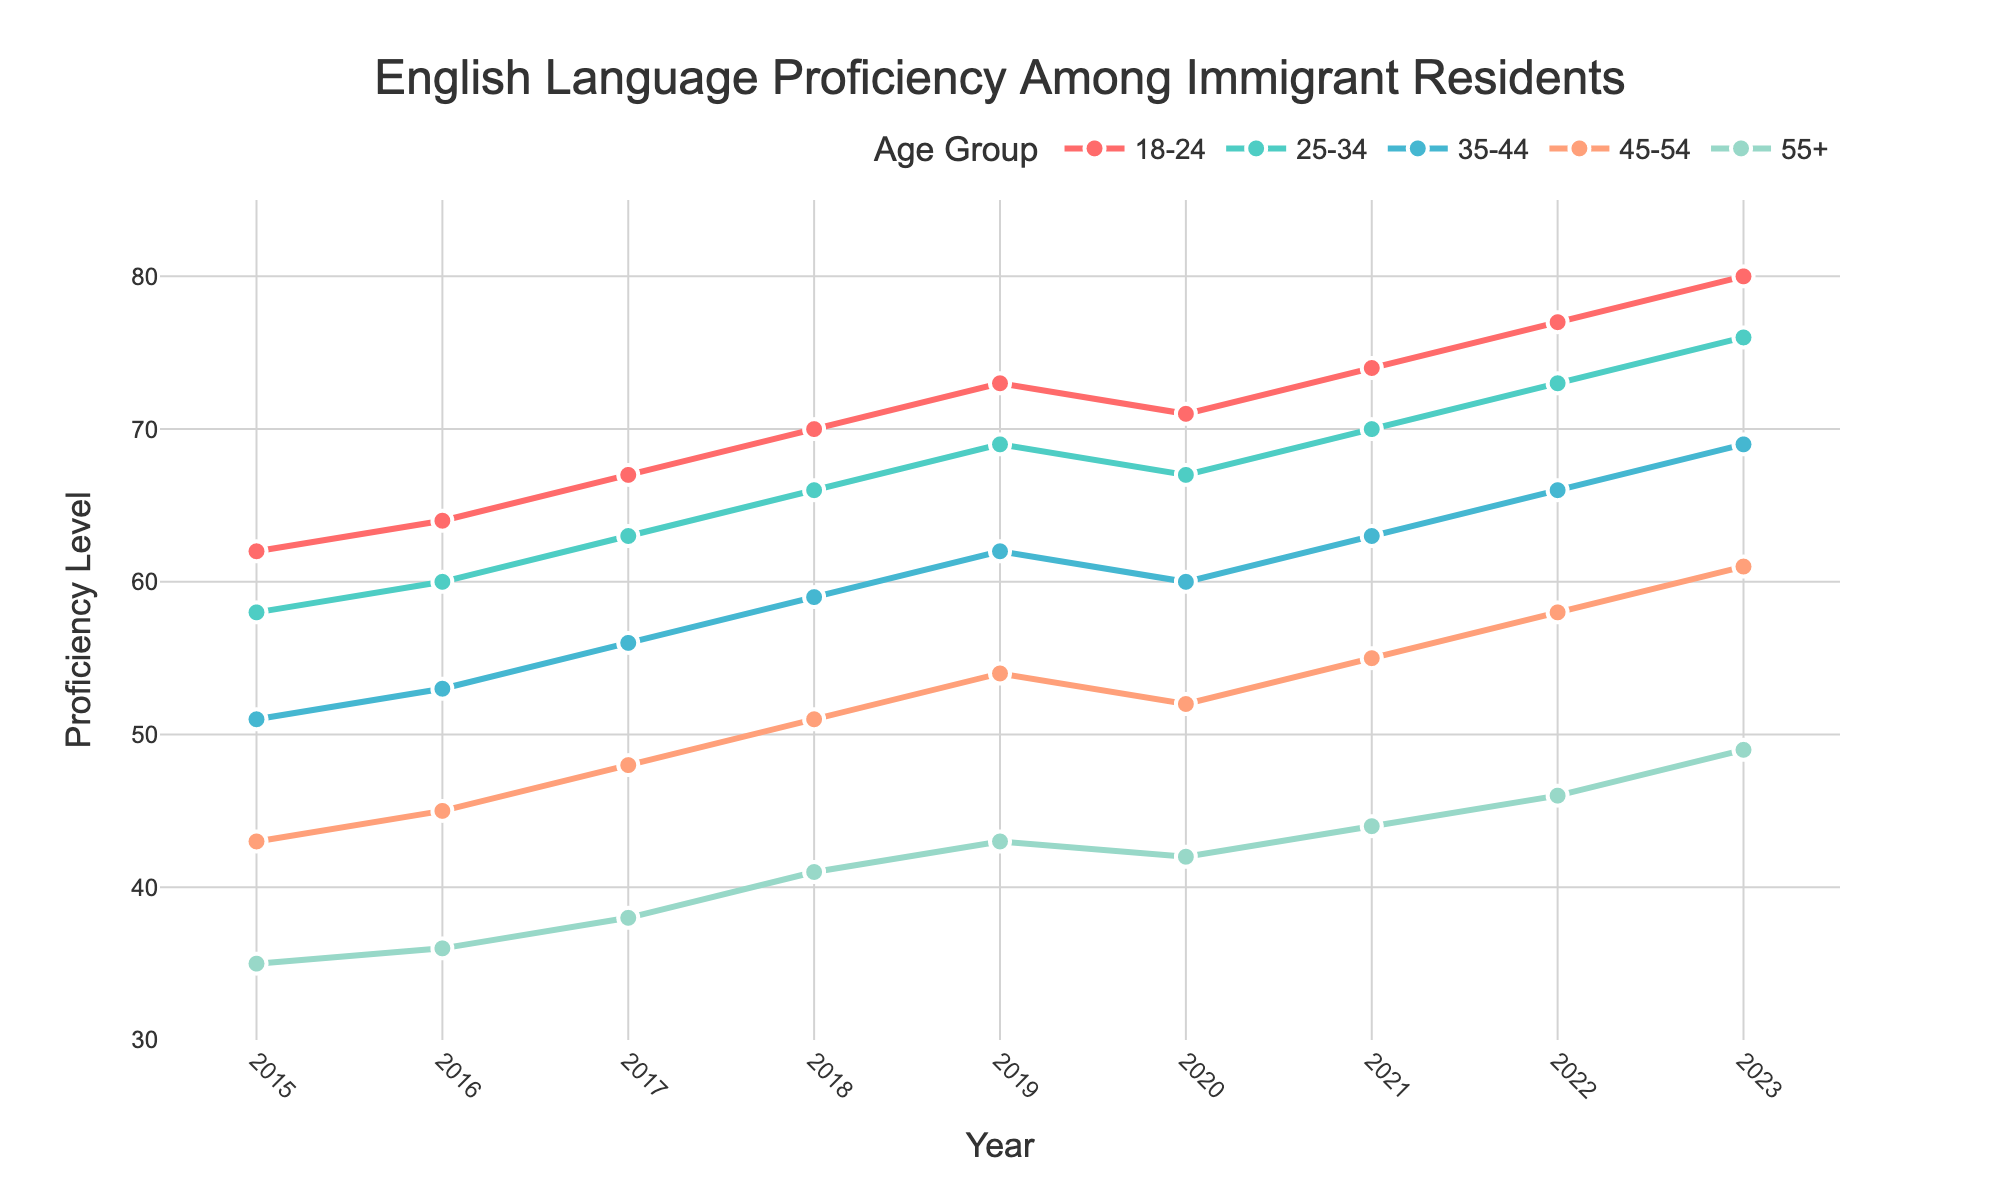what is the trend in English proficiency levels for residents aged 18-24 over the years? To determine the trend, look at the year-by-year values for the 18-24 age group. The proficiency levels are increasing steadily each year, starting from 62 in 2015 to 80 in 2023.
Answer: Increasing trend Which age group had the lowest proficiency level in 2023? To identify the age group with the lowest proficiency level in 2023, look at the values for each age group in that year. The 55+ age group had a proficiency level of 49, which is the lowest among all age groups.
Answer: 55+ How did the proficiency level of the 45-54 age group change between 2017 and 2021? Look at the proficiency levels of the 45-54 age group in 2017 and 2021. The levels were 48 in 2017 and 55 in 2021. The difference is 55 - 48 = 7. Therefore, proficiency increased by 7 points.
Answer: Increased by 7 points What is the percentage increase in proficiency for the 35-44 age group from 2015 to 2023? Calculate the percentage increase using the values for 2015 and 2023: ((69 - 51) / 51) * 100. The values are 51 in 2015 and 69 in 2023. The percentage increase is ((69 - 51) / 51) * 100 = 35.3%.
Answer: 35.3% In which year did the 55+ age group see their highest proficiency level? Look at the values for the 55+ age group across all years. The highest value is 49, which occurs in 2023.
Answer: 2023 Compare the proficiency levels of the 25-34 age group with the 18-24 age group in 2020. Which group had a higher proficiency? In 2020, the 25-34 age group had a proficiency level of 67 while the 18-24 age group had a level of 71. Therefore, the 18-24 age group had a higher proficiency.
Answer: 18-24 age group What is the average proficiency level of the 25-34 age group over the years? Sum the proficiency levels of the 25-34 age group from 2015 to 2023 and divide by the number of years: (58 + 60 + 63 + 66 + 69 + 67 + 70 + 73 + 76) / 9. The sum is 602, so the average is 602 / 9 = 66.9.
Answer: 66.9 Between which consecutive years did the 35-44 age group show the highest increase in proficiency? Calculate the differences between consecutive years for the 35-44 age group and identify the largest one. The differences are as follows: 2015-2016 = 53-51 = 2, 2016-2017 = 56-53 = 3, 2017-2018 = 59-56 = 3, 2018-2019 = 62-59 = 3, 2019-2020 = 60-62 = -2, 2020-2021 = 63-60 = 3, 2021-2022 = 66-63 = 3, 2022-2023 = 69-66 = 3. The highest increase (3 points) occurred between multiple intervals: 2016-2017, 2017-2018, 2018-2019, 2020-2021, 2021-2022, and 2022-2023
Answer: 2016-2017, 2017-2018, 2018-2019, 2020-2021, 2021-2022, 2022-2023 